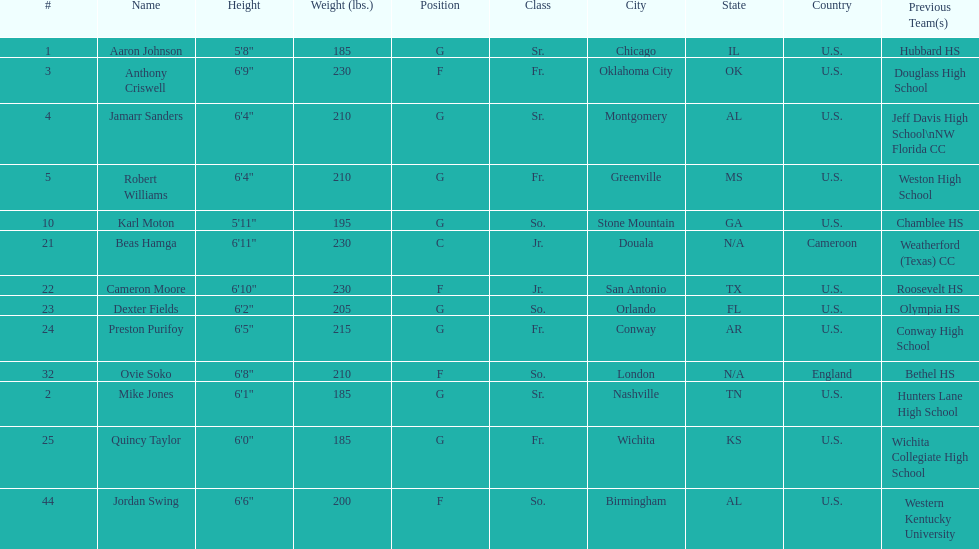How many players come from alabama? 2. 